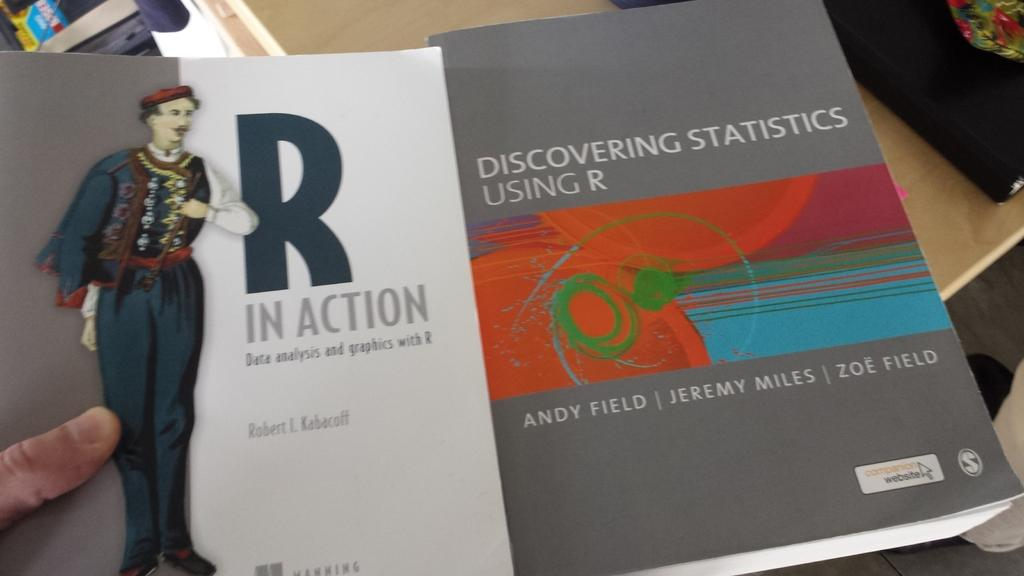<image>
Create a compact narrative representing the image presented. Book cover showing a man in a black and red outfit and "R In Action". 